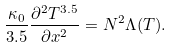<formula> <loc_0><loc_0><loc_500><loc_500>\frac { \kappa _ { 0 } } { 3 . 5 } \frac { \partial ^ { 2 } T ^ { 3 . 5 } } { \partial x ^ { 2 } } = N ^ { 2 } \Lambda ( T ) .</formula> 